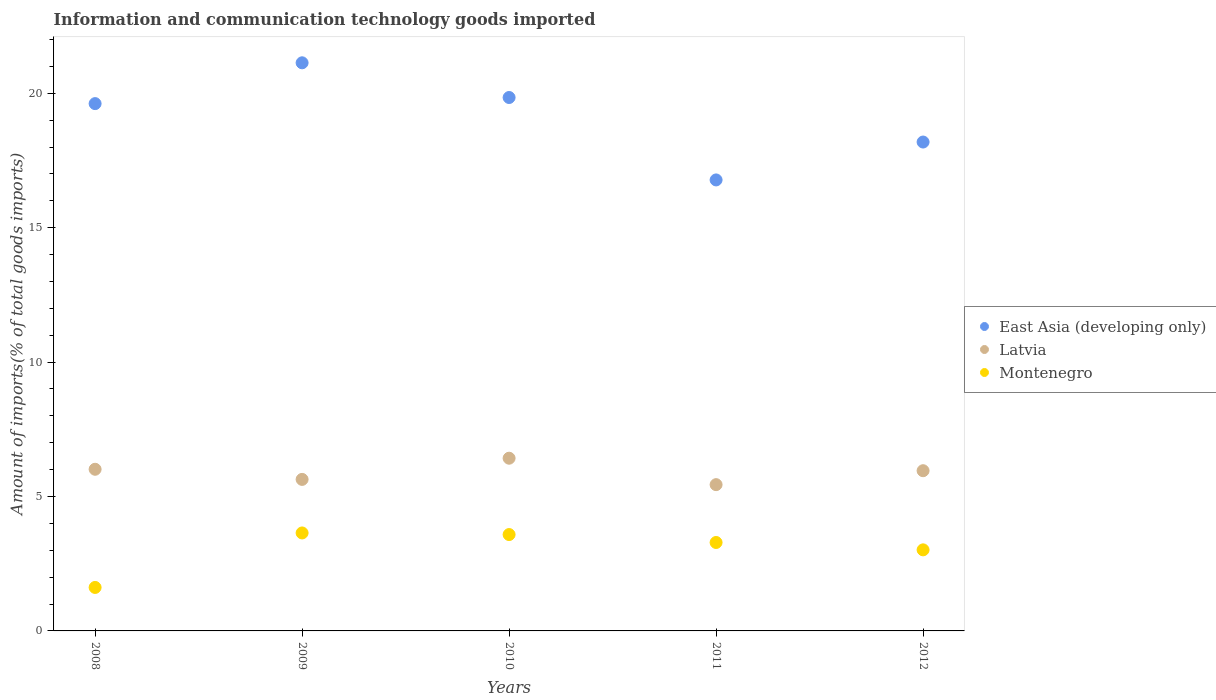How many different coloured dotlines are there?
Ensure brevity in your answer.  3. What is the amount of goods imported in Latvia in 2008?
Give a very brief answer. 6.01. Across all years, what is the maximum amount of goods imported in Montenegro?
Your answer should be compact. 3.64. Across all years, what is the minimum amount of goods imported in Latvia?
Your answer should be compact. 5.44. What is the total amount of goods imported in Latvia in the graph?
Your answer should be compact. 29.48. What is the difference between the amount of goods imported in Montenegro in 2009 and that in 2012?
Provide a short and direct response. 0.63. What is the difference between the amount of goods imported in East Asia (developing only) in 2011 and the amount of goods imported in Latvia in 2012?
Make the answer very short. 10.82. What is the average amount of goods imported in Latvia per year?
Your response must be concise. 5.9. In the year 2009, what is the difference between the amount of goods imported in Latvia and amount of goods imported in Montenegro?
Give a very brief answer. 1.99. In how many years, is the amount of goods imported in East Asia (developing only) greater than 15 %?
Provide a short and direct response. 5. What is the ratio of the amount of goods imported in East Asia (developing only) in 2009 to that in 2010?
Make the answer very short. 1.07. Is the difference between the amount of goods imported in Latvia in 2008 and 2012 greater than the difference between the amount of goods imported in Montenegro in 2008 and 2012?
Provide a succinct answer. Yes. What is the difference between the highest and the second highest amount of goods imported in Latvia?
Offer a very short reply. 0.41. What is the difference between the highest and the lowest amount of goods imported in Latvia?
Provide a short and direct response. 0.98. In how many years, is the amount of goods imported in Montenegro greater than the average amount of goods imported in Montenegro taken over all years?
Ensure brevity in your answer.  3. Is the amount of goods imported in Montenegro strictly less than the amount of goods imported in East Asia (developing only) over the years?
Offer a very short reply. Yes. Are the values on the major ticks of Y-axis written in scientific E-notation?
Give a very brief answer. No. Does the graph contain any zero values?
Ensure brevity in your answer.  No. Does the graph contain grids?
Give a very brief answer. No. How many legend labels are there?
Give a very brief answer. 3. How are the legend labels stacked?
Keep it short and to the point. Vertical. What is the title of the graph?
Your response must be concise. Information and communication technology goods imported. Does "Europe(all income levels)" appear as one of the legend labels in the graph?
Give a very brief answer. No. What is the label or title of the Y-axis?
Offer a very short reply. Amount of imports(% of total goods imports). What is the Amount of imports(% of total goods imports) in East Asia (developing only) in 2008?
Offer a terse response. 19.62. What is the Amount of imports(% of total goods imports) of Latvia in 2008?
Give a very brief answer. 6.01. What is the Amount of imports(% of total goods imports) in Montenegro in 2008?
Offer a very short reply. 1.62. What is the Amount of imports(% of total goods imports) in East Asia (developing only) in 2009?
Your answer should be compact. 21.13. What is the Amount of imports(% of total goods imports) of Latvia in 2009?
Give a very brief answer. 5.64. What is the Amount of imports(% of total goods imports) of Montenegro in 2009?
Ensure brevity in your answer.  3.64. What is the Amount of imports(% of total goods imports) of East Asia (developing only) in 2010?
Offer a very short reply. 19.84. What is the Amount of imports(% of total goods imports) of Latvia in 2010?
Offer a very short reply. 6.42. What is the Amount of imports(% of total goods imports) in Montenegro in 2010?
Offer a terse response. 3.58. What is the Amount of imports(% of total goods imports) in East Asia (developing only) in 2011?
Offer a very short reply. 16.78. What is the Amount of imports(% of total goods imports) of Latvia in 2011?
Offer a terse response. 5.44. What is the Amount of imports(% of total goods imports) in Montenegro in 2011?
Your answer should be very brief. 3.29. What is the Amount of imports(% of total goods imports) in East Asia (developing only) in 2012?
Provide a succinct answer. 18.19. What is the Amount of imports(% of total goods imports) in Latvia in 2012?
Offer a terse response. 5.96. What is the Amount of imports(% of total goods imports) of Montenegro in 2012?
Your answer should be compact. 3.02. Across all years, what is the maximum Amount of imports(% of total goods imports) in East Asia (developing only)?
Your answer should be compact. 21.13. Across all years, what is the maximum Amount of imports(% of total goods imports) in Latvia?
Offer a terse response. 6.42. Across all years, what is the maximum Amount of imports(% of total goods imports) in Montenegro?
Make the answer very short. 3.64. Across all years, what is the minimum Amount of imports(% of total goods imports) of East Asia (developing only)?
Provide a succinct answer. 16.78. Across all years, what is the minimum Amount of imports(% of total goods imports) of Latvia?
Your answer should be very brief. 5.44. Across all years, what is the minimum Amount of imports(% of total goods imports) in Montenegro?
Provide a succinct answer. 1.62. What is the total Amount of imports(% of total goods imports) of East Asia (developing only) in the graph?
Keep it short and to the point. 95.56. What is the total Amount of imports(% of total goods imports) in Latvia in the graph?
Offer a very short reply. 29.48. What is the total Amount of imports(% of total goods imports) of Montenegro in the graph?
Your answer should be compact. 15.15. What is the difference between the Amount of imports(% of total goods imports) of East Asia (developing only) in 2008 and that in 2009?
Offer a terse response. -1.52. What is the difference between the Amount of imports(% of total goods imports) in Latvia in 2008 and that in 2009?
Your answer should be very brief. 0.38. What is the difference between the Amount of imports(% of total goods imports) in Montenegro in 2008 and that in 2009?
Offer a terse response. -2.03. What is the difference between the Amount of imports(% of total goods imports) of East Asia (developing only) in 2008 and that in 2010?
Make the answer very short. -0.23. What is the difference between the Amount of imports(% of total goods imports) of Latvia in 2008 and that in 2010?
Your answer should be very brief. -0.41. What is the difference between the Amount of imports(% of total goods imports) of Montenegro in 2008 and that in 2010?
Provide a succinct answer. -1.97. What is the difference between the Amount of imports(% of total goods imports) of East Asia (developing only) in 2008 and that in 2011?
Your response must be concise. 2.84. What is the difference between the Amount of imports(% of total goods imports) in Latvia in 2008 and that in 2011?
Your answer should be compact. 0.57. What is the difference between the Amount of imports(% of total goods imports) in Montenegro in 2008 and that in 2011?
Make the answer very short. -1.67. What is the difference between the Amount of imports(% of total goods imports) in East Asia (developing only) in 2008 and that in 2012?
Your response must be concise. 1.43. What is the difference between the Amount of imports(% of total goods imports) of Latvia in 2008 and that in 2012?
Your answer should be compact. 0.05. What is the difference between the Amount of imports(% of total goods imports) in Montenegro in 2008 and that in 2012?
Offer a terse response. -1.4. What is the difference between the Amount of imports(% of total goods imports) in East Asia (developing only) in 2009 and that in 2010?
Your response must be concise. 1.29. What is the difference between the Amount of imports(% of total goods imports) in Latvia in 2009 and that in 2010?
Offer a terse response. -0.79. What is the difference between the Amount of imports(% of total goods imports) of Montenegro in 2009 and that in 2010?
Give a very brief answer. 0.06. What is the difference between the Amount of imports(% of total goods imports) in East Asia (developing only) in 2009 and that in 2011?
Your answer should be compact. 4.36. What is the difference between the Amount of imports(% of total goods imports) of Latvia in 2009 and that in 2011?
Provide a succinct answer. 0.2. What is the difference between the Amount of imports(% of total goods imports) of Montenegro in 2009 and that in 2011?
Ensure brevity in your answer.  0.35. What is the difference between the Amount of imports(% of total goods imports) in East Asia (developing only) in 2009 and that in 2012?
Provide a short and direct response. 2.95. What is the difference between the Amount of imports(% of total goods imports) in Latvia in 2009 and that in 2012?
Offer a very short reply. -0.32. What is the difference between the Amount of imports(% of total goods imports) of Montenegro in 2009 and that in 2012?
Your response must be concise. 0.63. What is the difference between the Amount of imports(% of total goods imports) in East Asia (developing only) in 2010 and that in 2011?
Keep it short and to the point. 3.07. What is the difference between the Amount of imports(% of total goods imports) in Latvia in 2010 and that in 2011?
Keep it short and to the point. 0.98. What is the difference between the Amount of imports(% of total goods imports) in Montenegro in 2010 and that in 2011?
Make the answer very short. 0.3. What is the difference between the Amount of imports(% of total goods imports) in East Asia (developing only) in 2010 and that in 2012?
Ensure brevity in your answer.  1.66. What is the difference between the Amount of imports(% of total goods imports) of Latvia in 2010 and that in 2012?
Provide a succinct answer. 0.46. What is the difference between the Amount of imports(% of total goods imports) of Montenegro in 2010 and that in 2012?
Your response must be concise. 0.57. What is the difference between the Amount of imports(% of total goods imports) of East Asia (developing only) in 2011 and that in 2012?
Offer a terse response. -1.41. What is the difference between the Amount of imports(% of total goods imports) in Latvia in 2011 and that in 2012?
Keep it short and to the point. -0.52. What is the difference between the Amount of imports(% of total goods imports) of Montenegro in 2011 and that in 2012?
Your answer should be very brief. 0.27. What is the difference between the Amount of imports(% of total goods imports) in East Asia (developing only) in 2008 and the Amount of imports(% of total goods imports) in Latvia in 2009?
Your answer should be very brief. 13.98. What is the difference between the Amount of imports(% of total goods imports) in East Asia (developing only) in 2008 and the Amount of imports(% of total goods imports) in Montenegro in 2009?
Give a very brief answer. 15.97. What is the difference between the Amount of imports(% of total goods imports) of Latvia in 2008 and the Amount of imports(% of total goods imports) of Montenegro in 2009?
Your answer should be compact. 2.37. What is the difference between the Amount of imports(% of total goods imports) in East Asia (developing only) in 2008 and the Amount of imports(% of total goods imports) in Latvia in 2010?
Make the answer very short. 13.19. What is the difference between the Amount of imports(% of total goods imports) of East Asia (developing only) in 2008 and the Amount of imports(% of total goods imports) of Montenegro in 2010?
Ensure brevity in your answer.  16.03. What is the difference between the Amount of imports(% of total goods imports) of Latvia in 2008 and the Amount of imports(% of total goods imports) of Montenegro in 2010?
Your answer should be compact. 2.43. What is the difference between the Amount of imports(% of total goods imports) in East Asia (developing only) in 2008 and the Amount of imports(% of total goods imports) in Latvia in 2011?
Offer a terse response. 14.17. What is the difference between the Amount of imports(% of total goods imports) in East Asia (developing only) in 2008 and the Amount of imports(% of total goods imports) in Montenegro in 2011?
Your response must be concise. 16.33. What is the difference between the Amount of imports(% of total goods imports) of Latvia in 2008 and the Amount of imports(% of total goods imports) of Montenegro in 2011?
Your answer should be very brief. 2.72. What is the difference between the Amount of imports(% of total goods imports) in East Asia (developing only) in 2008 and the Amount of imports(% of total goods imports) in Latvia in 2012?
Give a very brief answer. 13.66. What is the difference between the Amount of imports(% of total goods imports) of East Asia (developing only) in 2008 and the Amount of imports(% of total goods imports) of Montenegro in 2012?
Your answer should be very brief. 16.6. What is the difference between the Amount of imports(% of total goods imports) in Latvia in 2008 and the Amount of imports(% of total goods imports) in Montenegro in 2012?
Offer a very short reply. 3. What is the difference between the Amount of imports(% of total goods imports) of East Asia (developing only) in 2009 and the Amount of imports(% of total goods imports) of Latvia in 2010?
Your response must be concise. 14.71. What is the difference between the Amount of imports(% of total goods imports) in East Asia (developing only) in 2009 and the Amount of imports(% of total goods imports) in Montenegro in 2010?
Ensure brevity in your answer.  17.55. What is the difference between the Amount of imports(% of total goods imports) of Latvia in 2009 and the Amount of imports(% of total goods imports) of Montenegro in 2010?
Your answer should be very brief. 2.05. What is the difference between the Amount of imports(% of total goods imports) of East Asia (developing only) in 2009 and the Amount of imports(% of total goods imports) of Latvia in 2011?
Provide a succinct answer. 15.69. What is the difference between the Amount of imports(% of total goods imports) of East Asia (developing only) in 2009 and the Amount of imports(% of total goods imports) of Montenegro in 2011?
Provide a short and direct response. 17.84. What is the difference between the Amount of imports(% of total goods imports) in Latvia in 2009 and the Amount of imports(% of total goods imports) in Montenegro in 2011?
Provide a succinct answer. 2.35. What is the difference between the Amount of imports(% of total goods imports) of East Asia (developing only) in 2009 and the Amount of imports(% of total goods imports) of Latvia in 2012?
Keep it short and to the point. 15.17. What is the difference between the Amount of imports(% of total goods imports) of East Asia (developing only) in 2009 and the Amount of imports(% of total goods imports) of Montenegro in 2012?
Your answer should be compact. 18.12. What is the difference between the Amount of imports(% of total goods imports) of Latvia in 2009 and the Amount of imports(% of total goods imports) of Montenegro in 2012?
Ensure brevity in your answer.  2.62. What is the difference between the Amount of imports(% of total goods imports) in East Asia (developing only) in 2010 and the Amount of imports(% of total goods imports) in Latvia in 2011?
Provide a succinct answer. 14.4. What is the difference between the Amount of imports(% of total goods imports) in East Asia (developing only) in 2010 and the Amount of imports(% of total goods imports) in Montenegro in 2011?
Provide a succinct answer. 16.55. What is the difference between the Amount of imports(% of total goods imports) in Latvia in 2010 and the Amount of imports(% of total goods imports) in Montenegro in 2011?
Make the answer very short. 3.14. What is the difference between the Amount of imports(% of total goods imports) of East Asia (developing only) in 2010 and the Amount of imports(% of total goods imports) of Latvia in 2012?
Provide a short and direct response. 13.88. What is the difference between the Amount of imports(% of total goods imports) of East Asia (developing only) in 2010 and the Amount of imports(% of total goods imports) of Montenegro in 2012?
Give a very brief answer. 16.83. What is the difference between the Amount of imports(% of total goods imports) of Latvia in 2010 and the Amount of imports(% of total goods imports) of Montenegro in 2012?
Provide a short and direct response. 3.41. What is the difference between the Amount of imports(% of total goods imports) in East Asia (developing only) in 2011 and the Amount of imports(% of total goods imports) in Latvia in 2012?
Offer a very short reply. 10.82. What is the difference between the Amount of imports(% of total goods imports) in East Asia (developing only) in 2011 and the Amount of imports(% of total goods imports) in Montenegro in 2012?
Make the answer very short. 13.76. What is the difference between the Amount of imports(% of total goods imports) in Latvia in 2011 and the Amount of imports(% of total goods imports) in Montenegro in 2012?
Your response must be concise. 2.43. What is the average Amount of imports(% of total goods imports) of East Asia (developing only) per year?
Make the answer very short. 19.11. What is the average Amount of imports(% of total goods imports) of Latvia per year?
Your response must be concise. 5.9. What is the average Amount of imports(% of total goods imports) in Montenegro per year?
Your response must be concise. 3.03. In the year 2008, what is the difference between the Amount of imports(% of total goods imports) of East Asia (developing only) and Amount of imports(% of total goods imports) of Latvia?
Provide a succinct answer. 13.6. In the year 2008, what is the difference between the Amount of imports(% of total goods imports) in East Asia (developing only) and Amount of imports(% of total goods imports) in Montenegro?
Give a very brief answer. 18. In the year 2008, what is the difference between the Amount of imports(% of total goods imports) of Latvia and Amount of imports(% of total goods imports) of Montenegro?
Provide a short and direct response. 4.4. In the year 2009, what is the difference between the Amount of imports(% of total goods imports) in East Asia (developing only) and Amount of imports(% of total goods imports) in Latvia?
Ensure brevity in your answer.  15.5. In the year 2009, what is the difference between the Amount of imports(% of total goods imports) in East Asia (developing only) and Amount of imports(% of total goods imports) in Montenegro?
Your response must be concise. 17.49. In the year 2009, what is the difference between the Amount of imports(% of total goods imports) in Latvia and Amount of imports(% of total goods imports) in Montenegro?
Ensure brevity in your answer.  1.99. In the year 2010, what is the difference between the Amount of imports(% of total goods imports) of East Asia (developing only) and Amount of imports(% of total goods imports) of Latvia?
Provide a succinct answer. 13.42. In the year 2010, what is the difference between the Amount of imports(% of total goods imports) of East Asia (developing only) and Amount of imports(% of total goods imports) of Montenegro?
Offer a very short reply. 16.26. In the year 2010, what is the difference between the Amount of imports(% of total goods imports) of Latvia and Amount of imports(% of total goods imports) of Montenegro?
Offer a very short reply. 2.84. In the year 2011, what is the difference between the Amount of imports(% of total goods imports) in East Asia (developing only) and Amount of imports(% of total goods imports) in Latvia?
Give a very brief answer. 11.34. In the year 2011, what is the difference between the Amount of imports(% of total goods imports) in East Asia (developing only) and Amount of imports(% of total goods imports) in Montenegro?
Offer a very short reply. 13.49. In the year 2011, what is the difference between the Amount of imports(% of total goods imports) of Latvia and Amount of imports(% of total goods imports) of Montenegro?
Give a very brief answer. 2.15. In the year 2012, what is the difference between the Amount of imports(% of total goods imports) in East Asia (developing only) and Amount of imports(% of total goods imports) in Latvia?
Offer a very short reply. 12.23. In the year 2012, what is the difference between the Amount of imports(% of total goods imports) of East Asia (developing only) and Amount of imports(% of total goods imports) of Montenegro?
Provide a succinct answer. 15.17. In the year 2012, what is the difference between the Amount of imports(% of total goods imports) in Latvia and Amount of imports(% of total goods imports) in Montenegro?
Provide a succinct answer. 2.94. What is the ratio of the Amount of imports(% of total goods imports) in East Asia (developing only) in 2008 to that in 2009?
Your response must be concise. 0.93. What is the ratio of the Amount of imports(% of total goods imports) in Latvia in 2008 to that in 2009?
Offer a very short reply. 1.07. What is the ratio of the Amount of imports(% of total goods imports) of Montenegro in 2008 to that in 2009?
Give a very brief answer. 0.44. What is the ratio of the Amount of imports(% of total goods imports) of Latvia in 2008 to that in 2010?
Your answer should be compact. 0.94. What is the ratio of the Amount of imports(% of total goods imports) of Montenegro in 2008 to that in 2010?
Provide a short and direct response. 0.45. What is the ratio of the Amount of imports(% of total goods imports) of East Asia (developing only) in 2008 to that in 2011?
Offer a very short reply. 1.17. What is the ratio of the Amount of imports(% of total goods imports) of Latvia in 2008 to that in 2011?
Give a very brief answer. 1.11. What is the ratio of the Amount of imports(% of total goods imports) of Montenegro in 2008 to that in 2011?
Your answer should be compact. 0.49. What is the ratio of the Amount of imports(% of total goods imports) in East Asia (developing only) in 2008 to that in 2012?
Keep it short and to the point. 1.08. What is the ratio of the Amount of imports(% of total goods imports) in Latvia in 2008 to that in 2012?
Offer a terse response. 1.01. What is the ratio of the Amount of imports(% of total goods imports) of Montenegro in 2008 to that in 2012?
Keep it short and to the point. 0.54. What is the ratio of the Amount of imports(% of total goods imports) of East Asia (developing only) in 2009 to that in 2010?
Offer a terse response. 1.06. What is the ratio of the Amount of imports(% of total goods imports) of Latvia in 2009 to that in 2010?
Provide a succinct answer. 0.88. What is the ratio of the Amount of imports(% of total goods imports) of Montenegro in 2009 to that in 2010?
Your response must be concise. 1.02. What is the ratio of the Amount of imports(% of total goods imports) in East Asia (developing only) in 2009 to that in 2011?
Provide a short and direct response. 1.26. What is the ratio of the Amount of imports(% of total goods imports) in Latvia in 2009 to that in 2011?
Your response must be concise. 1.04. What is the ratio of the Amount of imports(% of total goods imports) of Montenegro in 2009 to that in 2011?
Your answer should be very brief. 1.11. What is the ratio of the Amount of imports(% of total goods imports) in East Asia (developing only) in 2009 to that in 2012?
Your response must be concise. 1.16. What is the ratio of the Amount of imports(% of total goods imports) in Latvia in 2009 to that in 2012?
Your answer should be very brief. 0.95. What is the ratio of the Amount of imports(% of total goods imports) of Montenegro in 2009 to that in 2012?
Your answer should be compact. 1.21. What is the ratio of the Amount of imports(% of total goods imports) of East Asia (developing only) in 2010 to that in 2011?
Your answer should be very brief. 1.18. What is the ratio of the Amount of imports(% of total goods imports) in Latvia in 2010 to that in 2011?
Ensure brevity in your answer.  1.18. What is the ratio of the Amount of imports(% of total goods imports) in Montenegro in 2010 to that in 2011?
Give a very brief answer. 1.09. What is the ratio of the Amount of imports(% of total goods imports) of East Asia (developing only) in 2010 to that in 2012?
Make the answer very short. 1.09. What is the ratio of the Amount of imports(% of total goods imports) in Latvia in 2010 to that in 2012?
Your response must be concise. 1.08. What is the ratio of the Amount of imports(% of total goods imports) of Montenegro in 2010 to that in 2012?
Offer a terse response. 1.19. What is the ratio of the Amount of imports(% of total goods imports) in East Asia (developing only) in 2011 to that in 2012?
Offer a terse response. 0.92. What is the ratio of the Amount of imports(% of total goods imports) in Latvia in 2011 to that in 2012?
Provide a short and direct response. 0.91. What is the ratio of the Amount of imports(% of total goods imports) of Montenegro in 2011 to that in 2012?
Your response must be concise. 1.09. What is the difference between the highest and the second highest Amount of imports(% of total goods imports) of East Asia (developing only)?
Your answer should be compact. 1.29. What is the difference between the highest and the second highest Amount of imports(% of total goods imports) of Latvia?
Provide a short and direct response. 0.41. What is the difference between the highest and the second highest Amount of imports(% of total goods imports) in Montenegro?
Your answer should be compact. 0.06. What is the difference between the highest and the lowest Amount of imports(% of total goods imports) in East Asia (developing only)?
Your answer should be compact. 4.36. What is the difference between the highest and the lowest Amount of imports(% of total goods imports) in Latvia?
Your answer should be very brief. 0.98. What is the difference between the highest and the lowest Amount of imports(% of total goods imports) of Montenegro?
Provide a succinct answer. 2.03. 